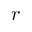<formula> <loc_0><loc_0><loc_500><loc_500>r</formula> 